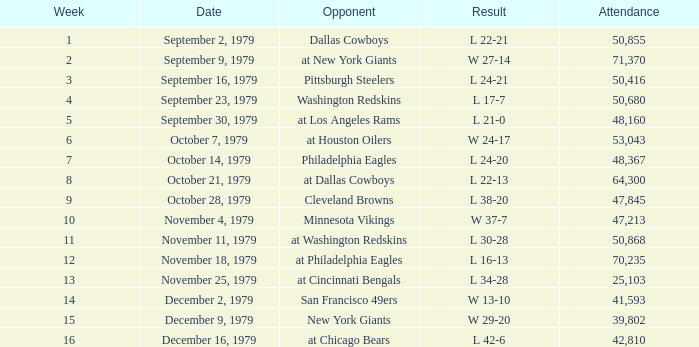What outcome in a week beyond 2 happened with a presence exceeding 53,043 on november 18, 1979? L 16-13. 